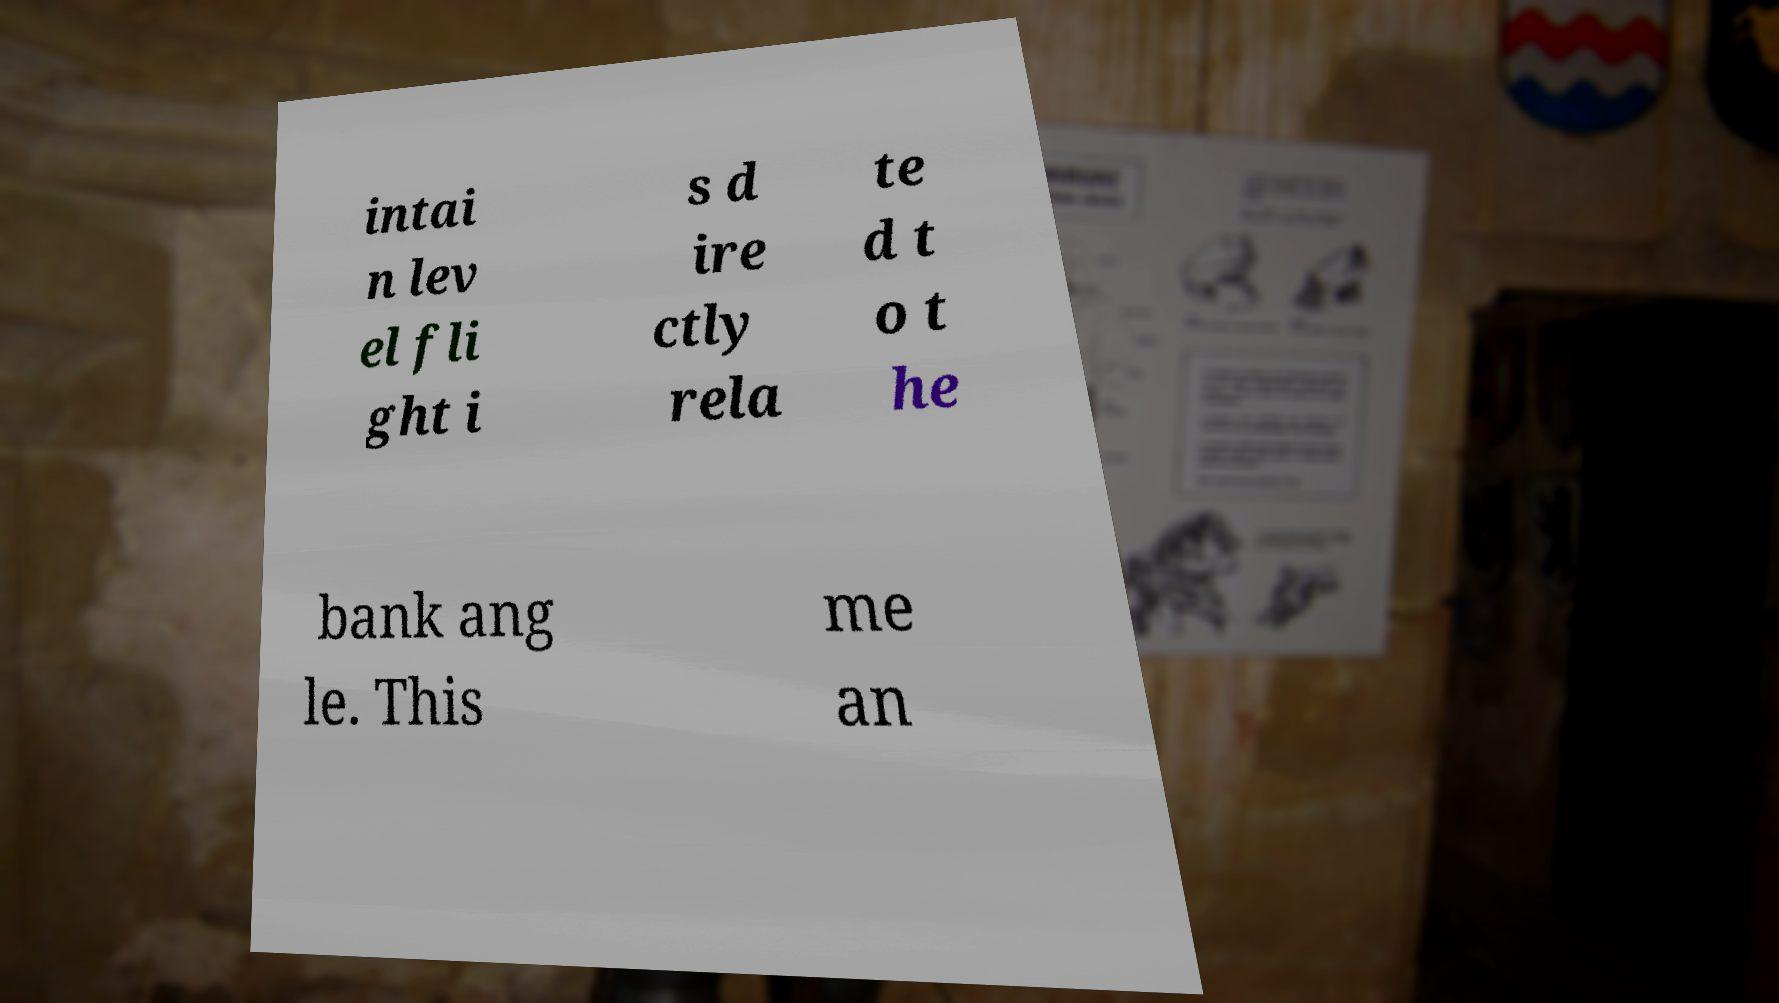Can you accurately transcribe the text from the provided image for me? intai n lev el fli ght i s d ire ctly rela te d t o t he bank ang le. This me an 